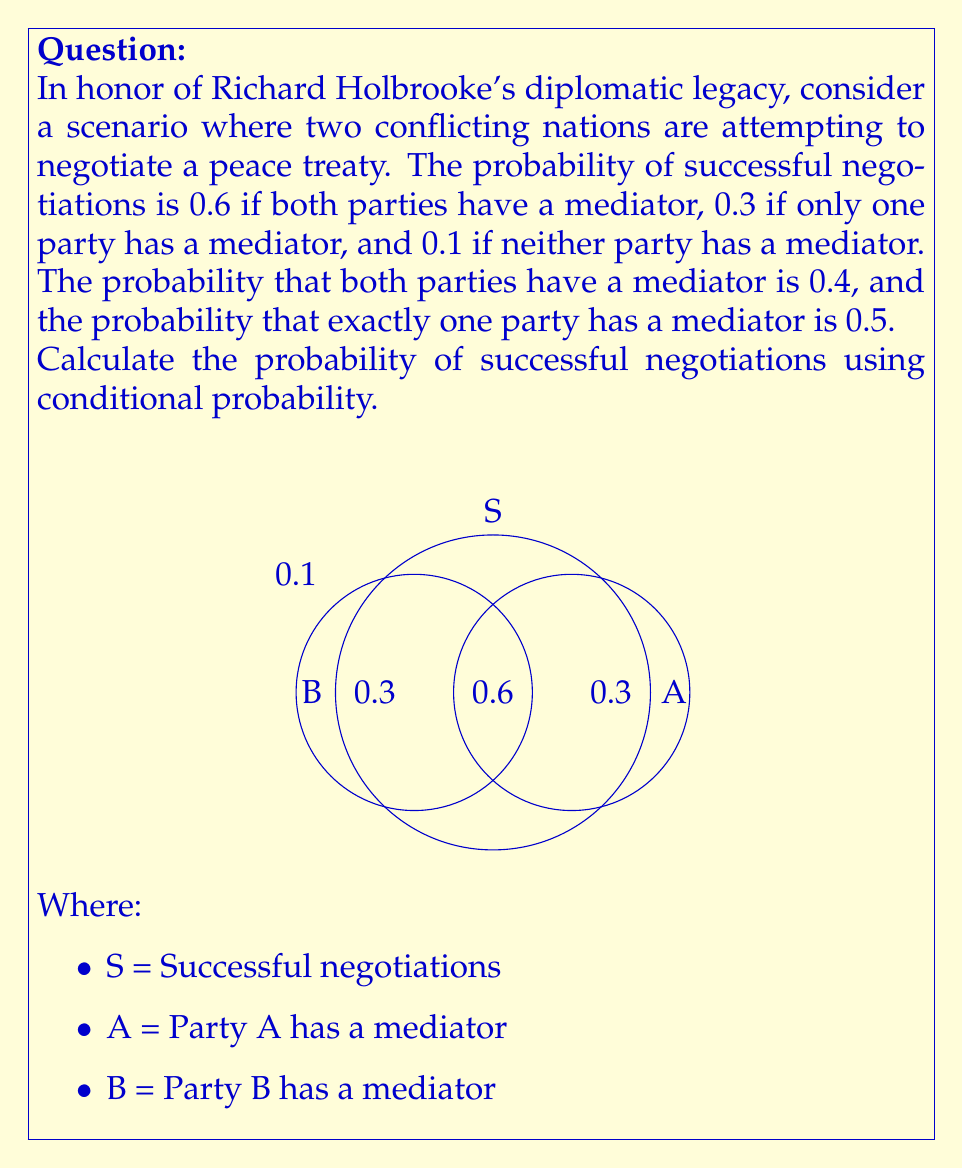Help me with this question. Let's approach this step-by-step using the law of total probability:

1) Define events:
   S: Successful negotiations
   M: Both parties have a mediator
   O: Only one party has a mediator
   N: Neither party has a mediator

2) Given probabilities:
   P(S|M) = 0.6
   P(S|O) = 0.3
   P(S|N) = 0.1
   P(M) = 0.4
   P(O) = 0.5
   P(N) = 1 - P(M) - P(O) = 1 - 0.4 - 0.5 = 0.1

3) Law of Total Probability:
   $$P(S) = P(S|M)P(M) + P(S|O)P(O) + P(S|N)P(N)$$

4) Substituting the values:
   $$P(S) = (0.6)(0.4) + (0.3)(0.5) + (0.1)(0.1)$$

5) Calculating:
   $$P(S) = 0.24 + 0.15 + 0.01 = 0.40$$

Therefore, the probability of successful negotiations is 0.40 or 40%.
Answer: 0.40 